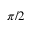<formula> <loc_0><loc_0><loc_500><loc_500>\pi / 2</formula> 